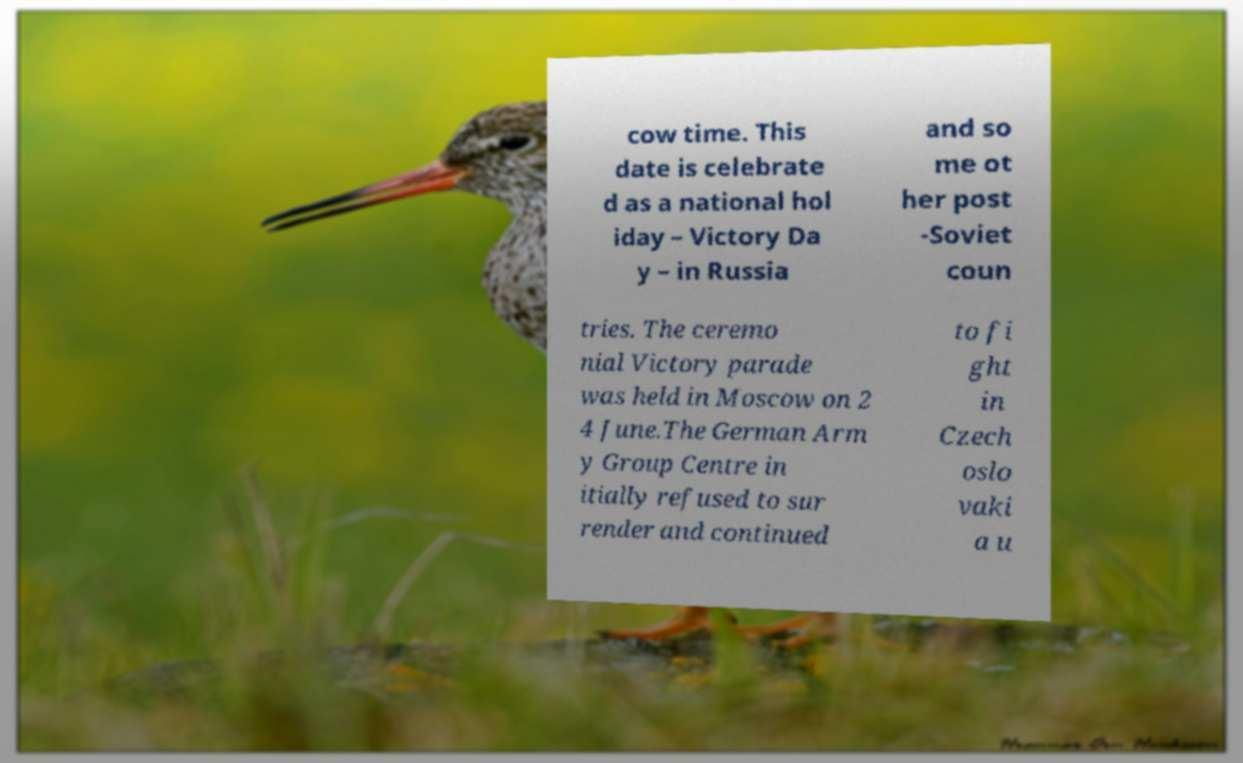Could you assist in decoding the text presented in this image and type it out clearly? cow time. This date is celebrate d as a national hol iday – Victory Da y – in Russia and so me ot her post -Soviet coun tries. The ceremo nial Victory parade was held in Moscow on 2 4 June.The German Arm y Group Centre in itially refused to sur render and continued to fi ght in Czech oslo vaki a u 